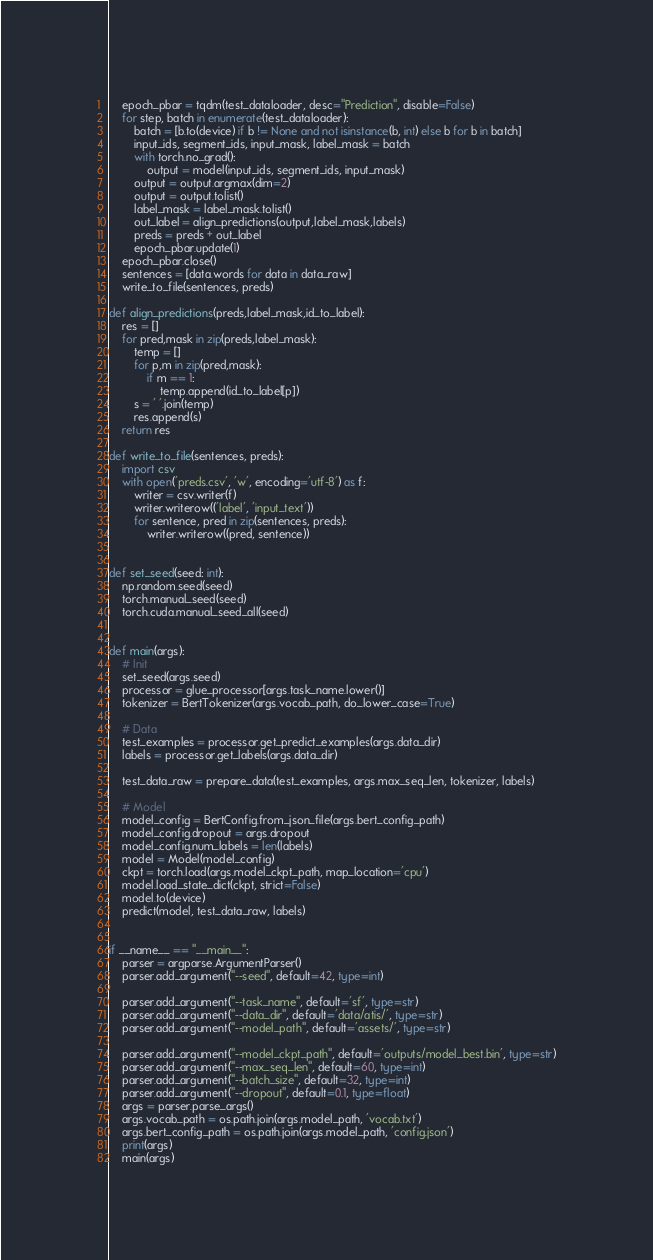Convert code to text. <code><loc_0><loc_0><loc_500><loc_500><_Python_>    epoch_pbar = tqdm(test_dataloader, desc="Prediction", disable=False)
    for step, batch in enumerate(test_dataloader):
        batch = [b.to(device) if b != None and not isinstance(b, int) else b for b in batch]
        input_ids, segment_ids, input_mask, label_mask = batch
        with torch.no_grad():
            output = model(input_ids, segment_ids, input_mask)
        output = output.argmax(dim=2)
        output = output.tolist()
        label_mask = label_mask.tolist()
        out_label = align_predictions(output,label_mask,labels)
        preds = preds + out_label
        epoch_pbar.update(1)
    epoch_pbar.close()
    sentences = [data.words for data in data_raw]
    write_to_file(sentences, preds)

def align_predictions(preds,label_mask,id_to_label):
    res = []
    for pred,mask in zip(preds,label_mask):
        temp = []
        for p,m in zip(pred,mask):
            if m == 1:
                temp.append(id_to_label[p])
        s = ' '.join(temp)
        res.append(s)
    return res

def write_to_file(sentences, preds):
    import csv
    with open('preds.csv', 'w', encoding='utf-8') as f:
        writer = csv.writer(f)
        writer.writerow(('label', 'input_text'))
        for sentence, pred in zip(sentences, preds):
            writer.writerow((pred, sentence))


def set_seed(seed: int):
    np.random.seed(seed)
    torch.manual_seed(seed)
    torch.cuda.manual_seed_all(seed)


def main(args):
    # Init
    set_seed(args.seed)
    processor = glue_processor[args.task_name.lower()]
    tokenizer = BertTokenizer(args.vocab_path, do_lower_case=True)

    # Data
    test_examples = processor.get_predict_examples(args.data_dir)
    labels = processor.get_labels(args.data_dir)

    test_data_raw = prepare_data(test_examples, args.max_seq_len, tokenizer, labels)

    # Model
    model_config = BertConfig.from_json_file(args.bert_config_path)
    model_config.dropout = args.dropout
    model_config.num_labels = len(labels)
    model = Model(model_config)
    ckpt = torch.load(args.model_ckpt_path, map_location='cpu')
    model.load_state_dict(ckpt, strict=False)
    model.to(device)
    predict(model, test_data_raw, labels)


if __name__ == "__main__":
    parser = argparse.ArgumentParser()
    parser.add_argument("--seed", default=42, type=int)

    parser.add_argument("--task_name", default='sf', type=str)
    parser.add_argument("--data_dir", default='data/atis/', type=str)
    parser.add_argument("--model_path", default='assets/', type=str)

    parser.add_argument("--model_ckpt_path", default='outputs/model_best.bin', type=str)
    parser.add_argument("--max_seq_len", default=60, type=int)
    parser.add_argument("--batch_size", default=32, type=int)
    parser.add_argument("--dropout", default=0.1, type=float)
    args = parser.parse_args()
    args.vocab_path = os.path.join(args.model_path, 'vocab.txt')
    args.bert_config_path = os.path.join(args.model_path, 'config.json')
    print(args)
    main(args)
</code> 